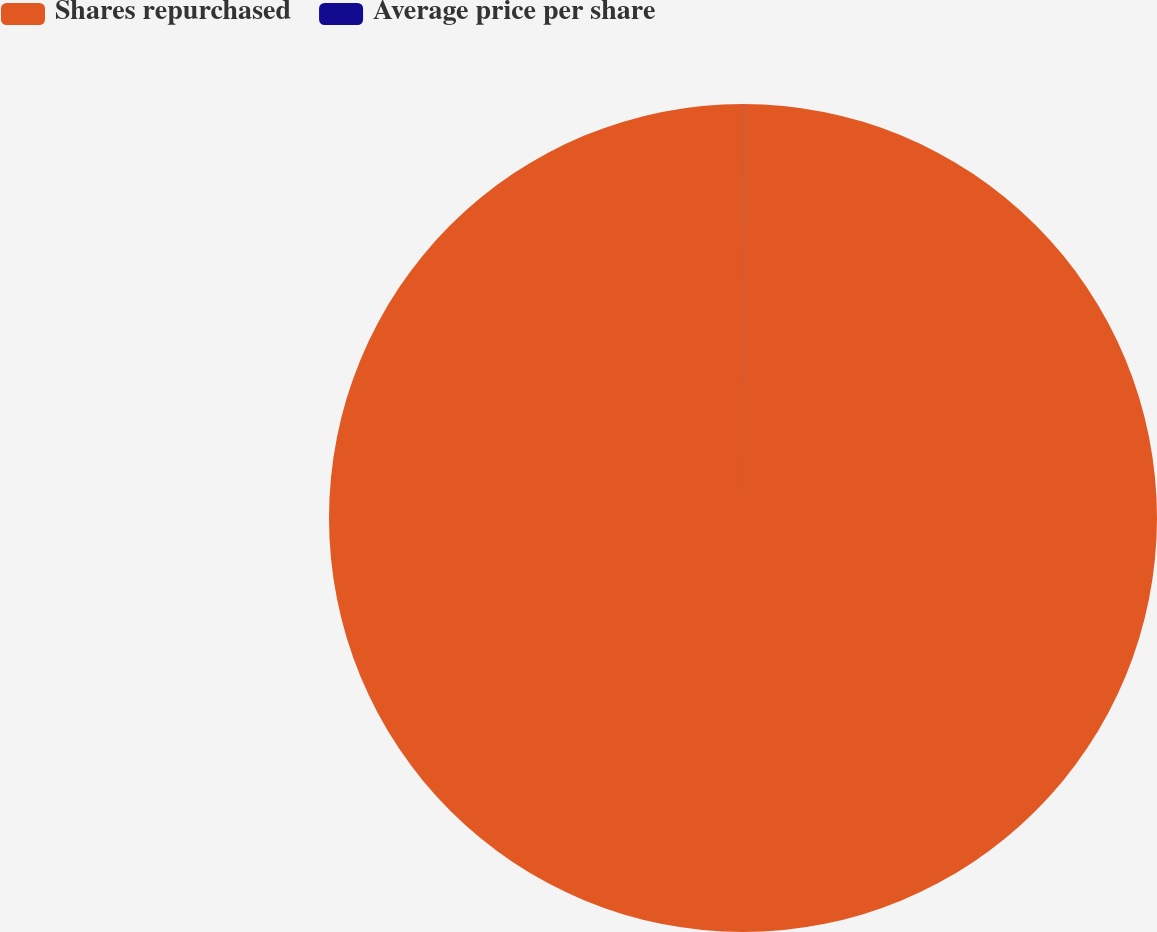Convert chart. <chart><loc_0><loc_0><loc_500><loc_500><pie_chart><fcel>Shares repurchased<fcel>Average price per share<nl><fcel>99.99%<fcel>0.01%<nl></chart> 